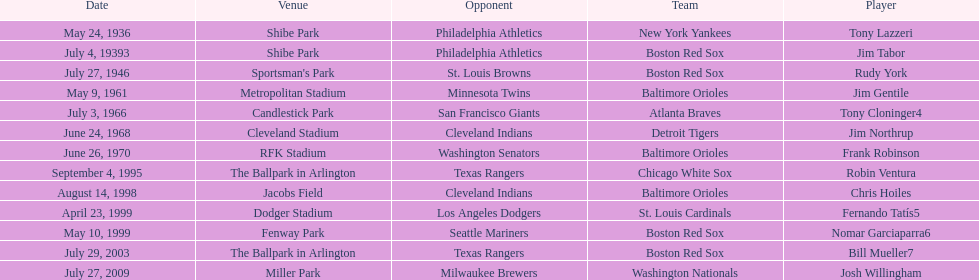On what date did the detroit tigers play the cleveland indians? June 24, 1968. 